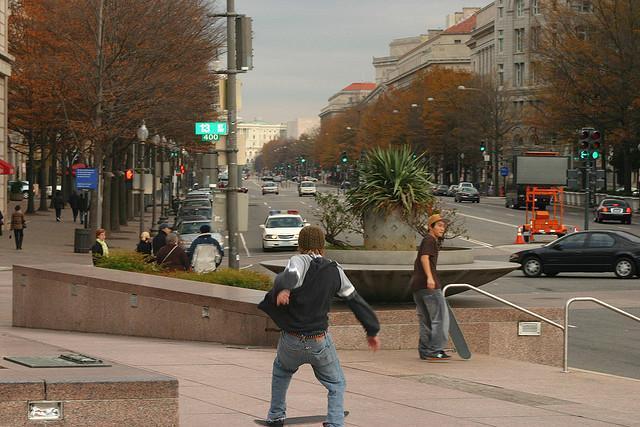How many stair railings can be seen?
Give a very brief answer. 2. How many potted plants are there?
Give a very brief answer. 2. How many people are there?
Give a very brief answer. 2. 